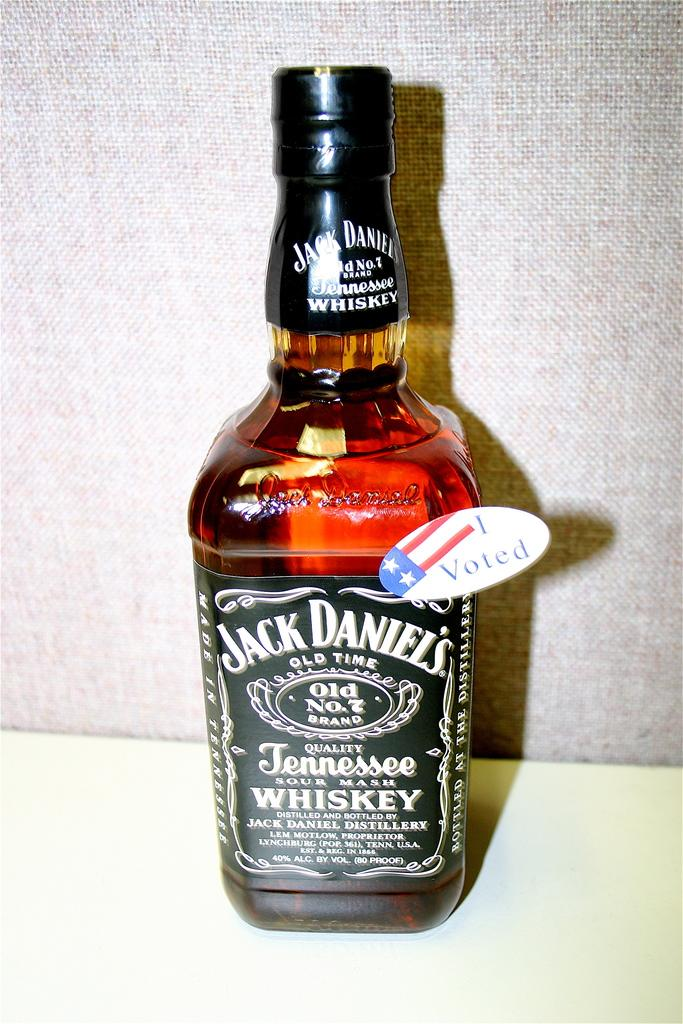<image>
Provide a brief description of the given image. Jack Daniels Whiskey is printed on the label of this liquor bottle. 